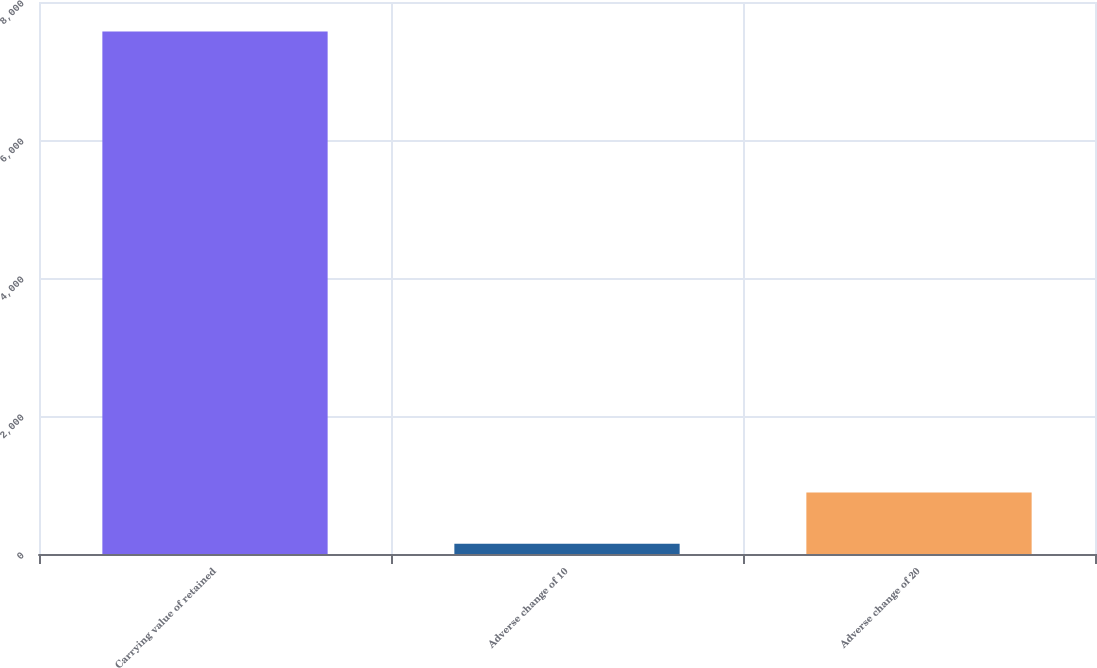Convert chart. <chart><loc_0><loc_0><loc_500><loc_500><bar_chart><fcel>Carrying value of retained<fcel>Adverse change of 10<fcel>Adverse change of 20<nl><fcel>7571<fcel>149<fcel>891.2<nl></chart> 